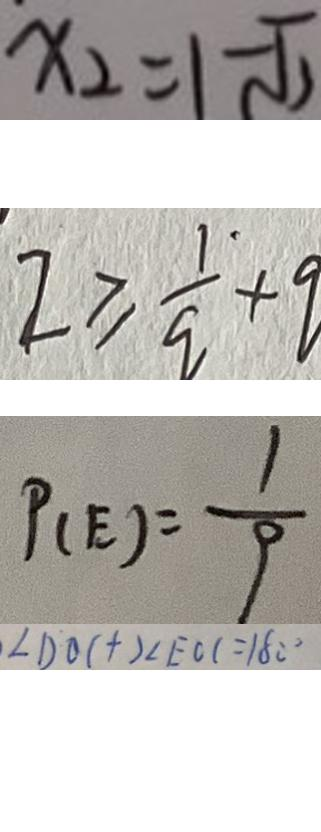<formula> <loc_0><loc_0><loc_500><loc_500>x _ { 2 } = 1 - \sqrt { 2 } 
 2 \geq \frac { 1 } { q } + q 
 P _ { ( E ) } = \frac { 1 } { 9 } 
 \angle D O C + 2 \angle E C C = 1 8 0 ^ { \circ }</formula> 